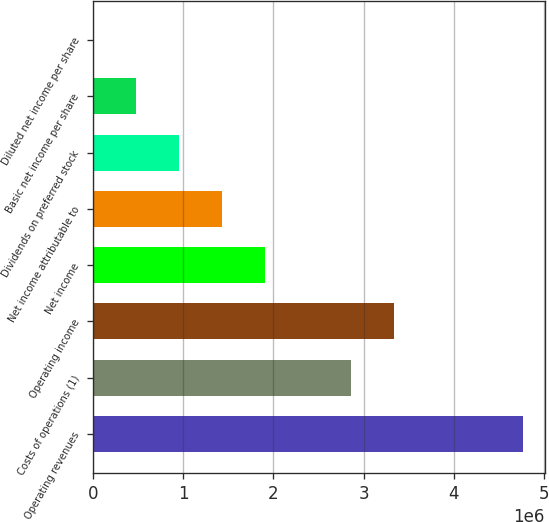Convert chart to OTSL. <chart><loc_0><loc_0><loc_500><loc_500><bar_chart><fcel>Operating revenues<fcel>Costs of operations (1)<fcel>Operating income<fcel>Net income<fcel>Net income attributable to<fcel>Dividends on preferred stock<fcel>Basic net income per share<fcel>Diluted net income per share<nl><fcel>4.77152e+06<fcel>2.86291e+06<fcel>3.34006e+06<fcel>1.90861e+06<fcel>1.43146e+06<fcel>954304<fcel>477153<fcel>1.41<nl></chart> 